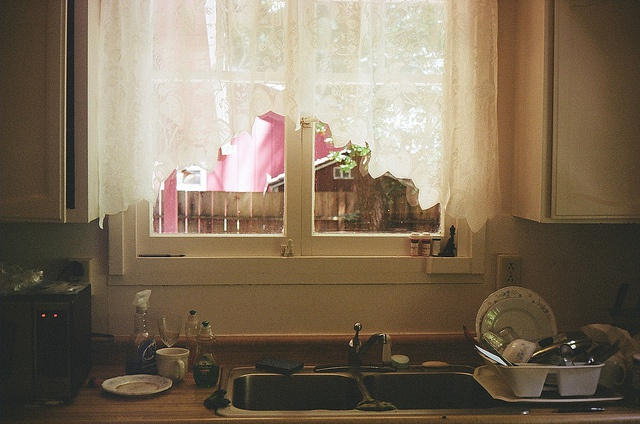Describe the objects in this image and their specific colors. I can see sink in black, gray, and olive tones, microwave in black, darkgreen, and gray tones, bottle in black, maroon, and gray tones, bottle in black and gray tones, and cup in black and gray tones in this image. 